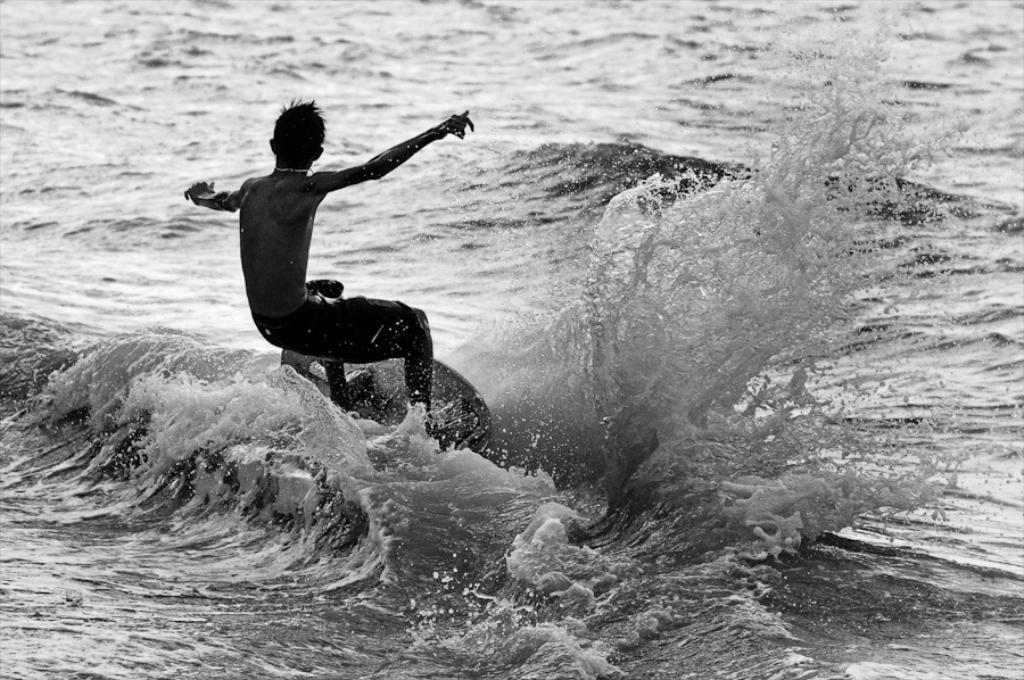What is the person in the image doing? The person is surfing. What is the setting for this activity? There is a water body in the image. What type of linen is being used to make the surfboard in the image? There is no mention of a surfboard being made of linen in the image. The surfboard, if present, could be made of various materials, but linen is not mentioned in the provided facts. 